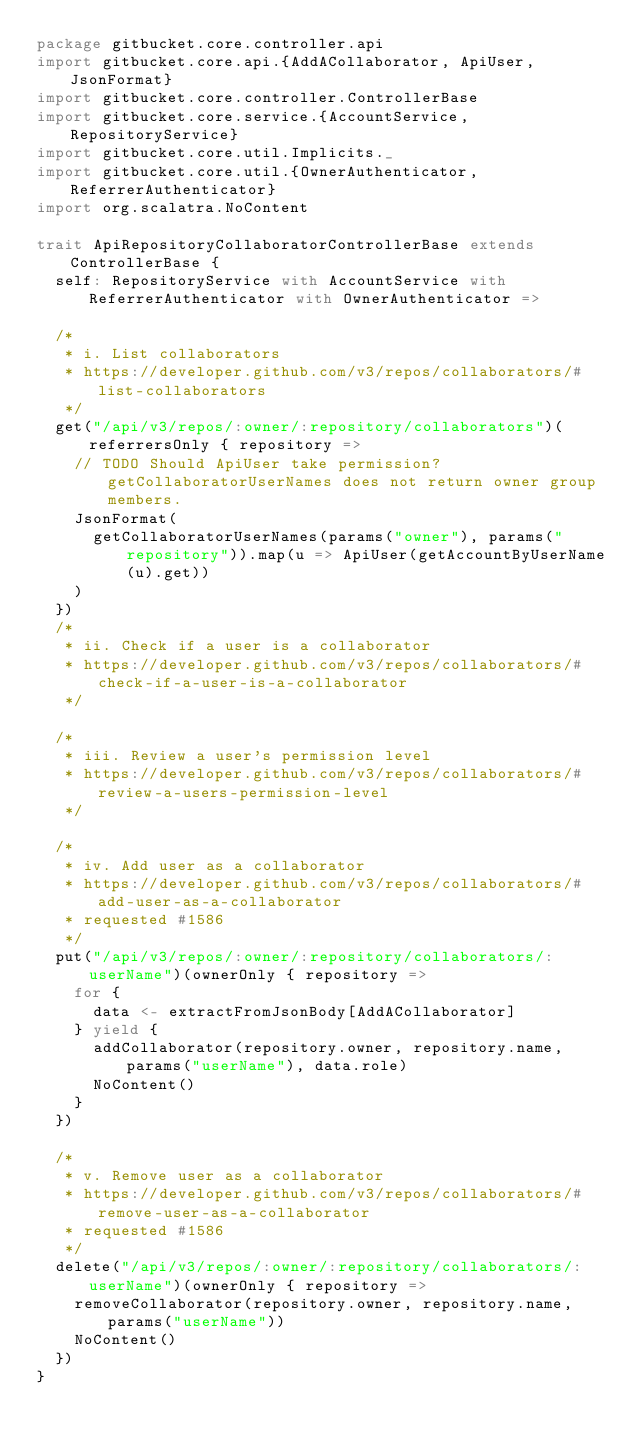Convert code to text. <code><loc_0><loc_0><loc_500><loc_500><_Scala_>package gitbucket.core.controller.api
import gitbucket.core.api.{AddACollaborator, ApiUser, JsonFormat}
import gitbucket.core.controller.ControllerBase
import gitbucket.core.service.{AccountService, RepositoryService}
import gitbucket.core.util.Implicits._
import gitbucket.core.util.{OwnerAuthenticator, ReferrerAuthenticator}
import org.scalatra.NoContent

trait ApiRepositoryCollaboratorControllerBase extends ControllerBase {
  self: RepositoryService with AccountService with ReferrerAuthenticator with OwnerAuthenticator =>

  /*
   * i. List collaborators
   * https://developer.github.com/v3/repos/collaborators/#list-collaborators
   */
  get("/api/v3/repos/:owner/:repository/collaborators")(referrersOnly { repository =>
    // TODO Should ApiUser take permission? getCollaboratorUserNames does not return owner group members.
    JsonFormat(
      getCollaboratorUserNames(params("owner"), params("repository")).map(u => ApiUser(getAccountByUserName(u).get))
    )
  })
  /*
   * ii. Check if a user is a collaborator
   * https://developer.github.com/v3/repos/collaborators/#check-if-a-user-is-a-collaborator
   */

  /*
   * iii. Review a user's permission level
   * https://developer.github.com/v3/repos/collaborators/#review-a-users-permission-level
   */

  /*
   * iv. Add user as a collaborator
   * https://developer.github.com/v3/repos/collaborators/#add-user-as-a-collaborator
   * requested #1586
   */
  put("/api/v3/repos/:owner/:repository/collaborators/:userName")(ownerOnly { repository =>
    for {
      data <- extractFromJsonBody[AddACollaborator]
    } yield {
      addCollaborator(repository.owner, repository.name, params("userName"), data.role)
      NoContent()
    }
  })

  /*
   * v. Remove user as a collaborator
   * https://developer.github.com/v3/repos/collaborators/#remove-user-as-a-collaborator
   * requested #1586
   */
  delete("/api/v3/repos/:owner/:repository/collaborators/:userName")(ownerOnly { repository =>
    removeCollaborator(repository.owner, repository.name, params("userName"))
    NoContent()
  })
}
</code> 